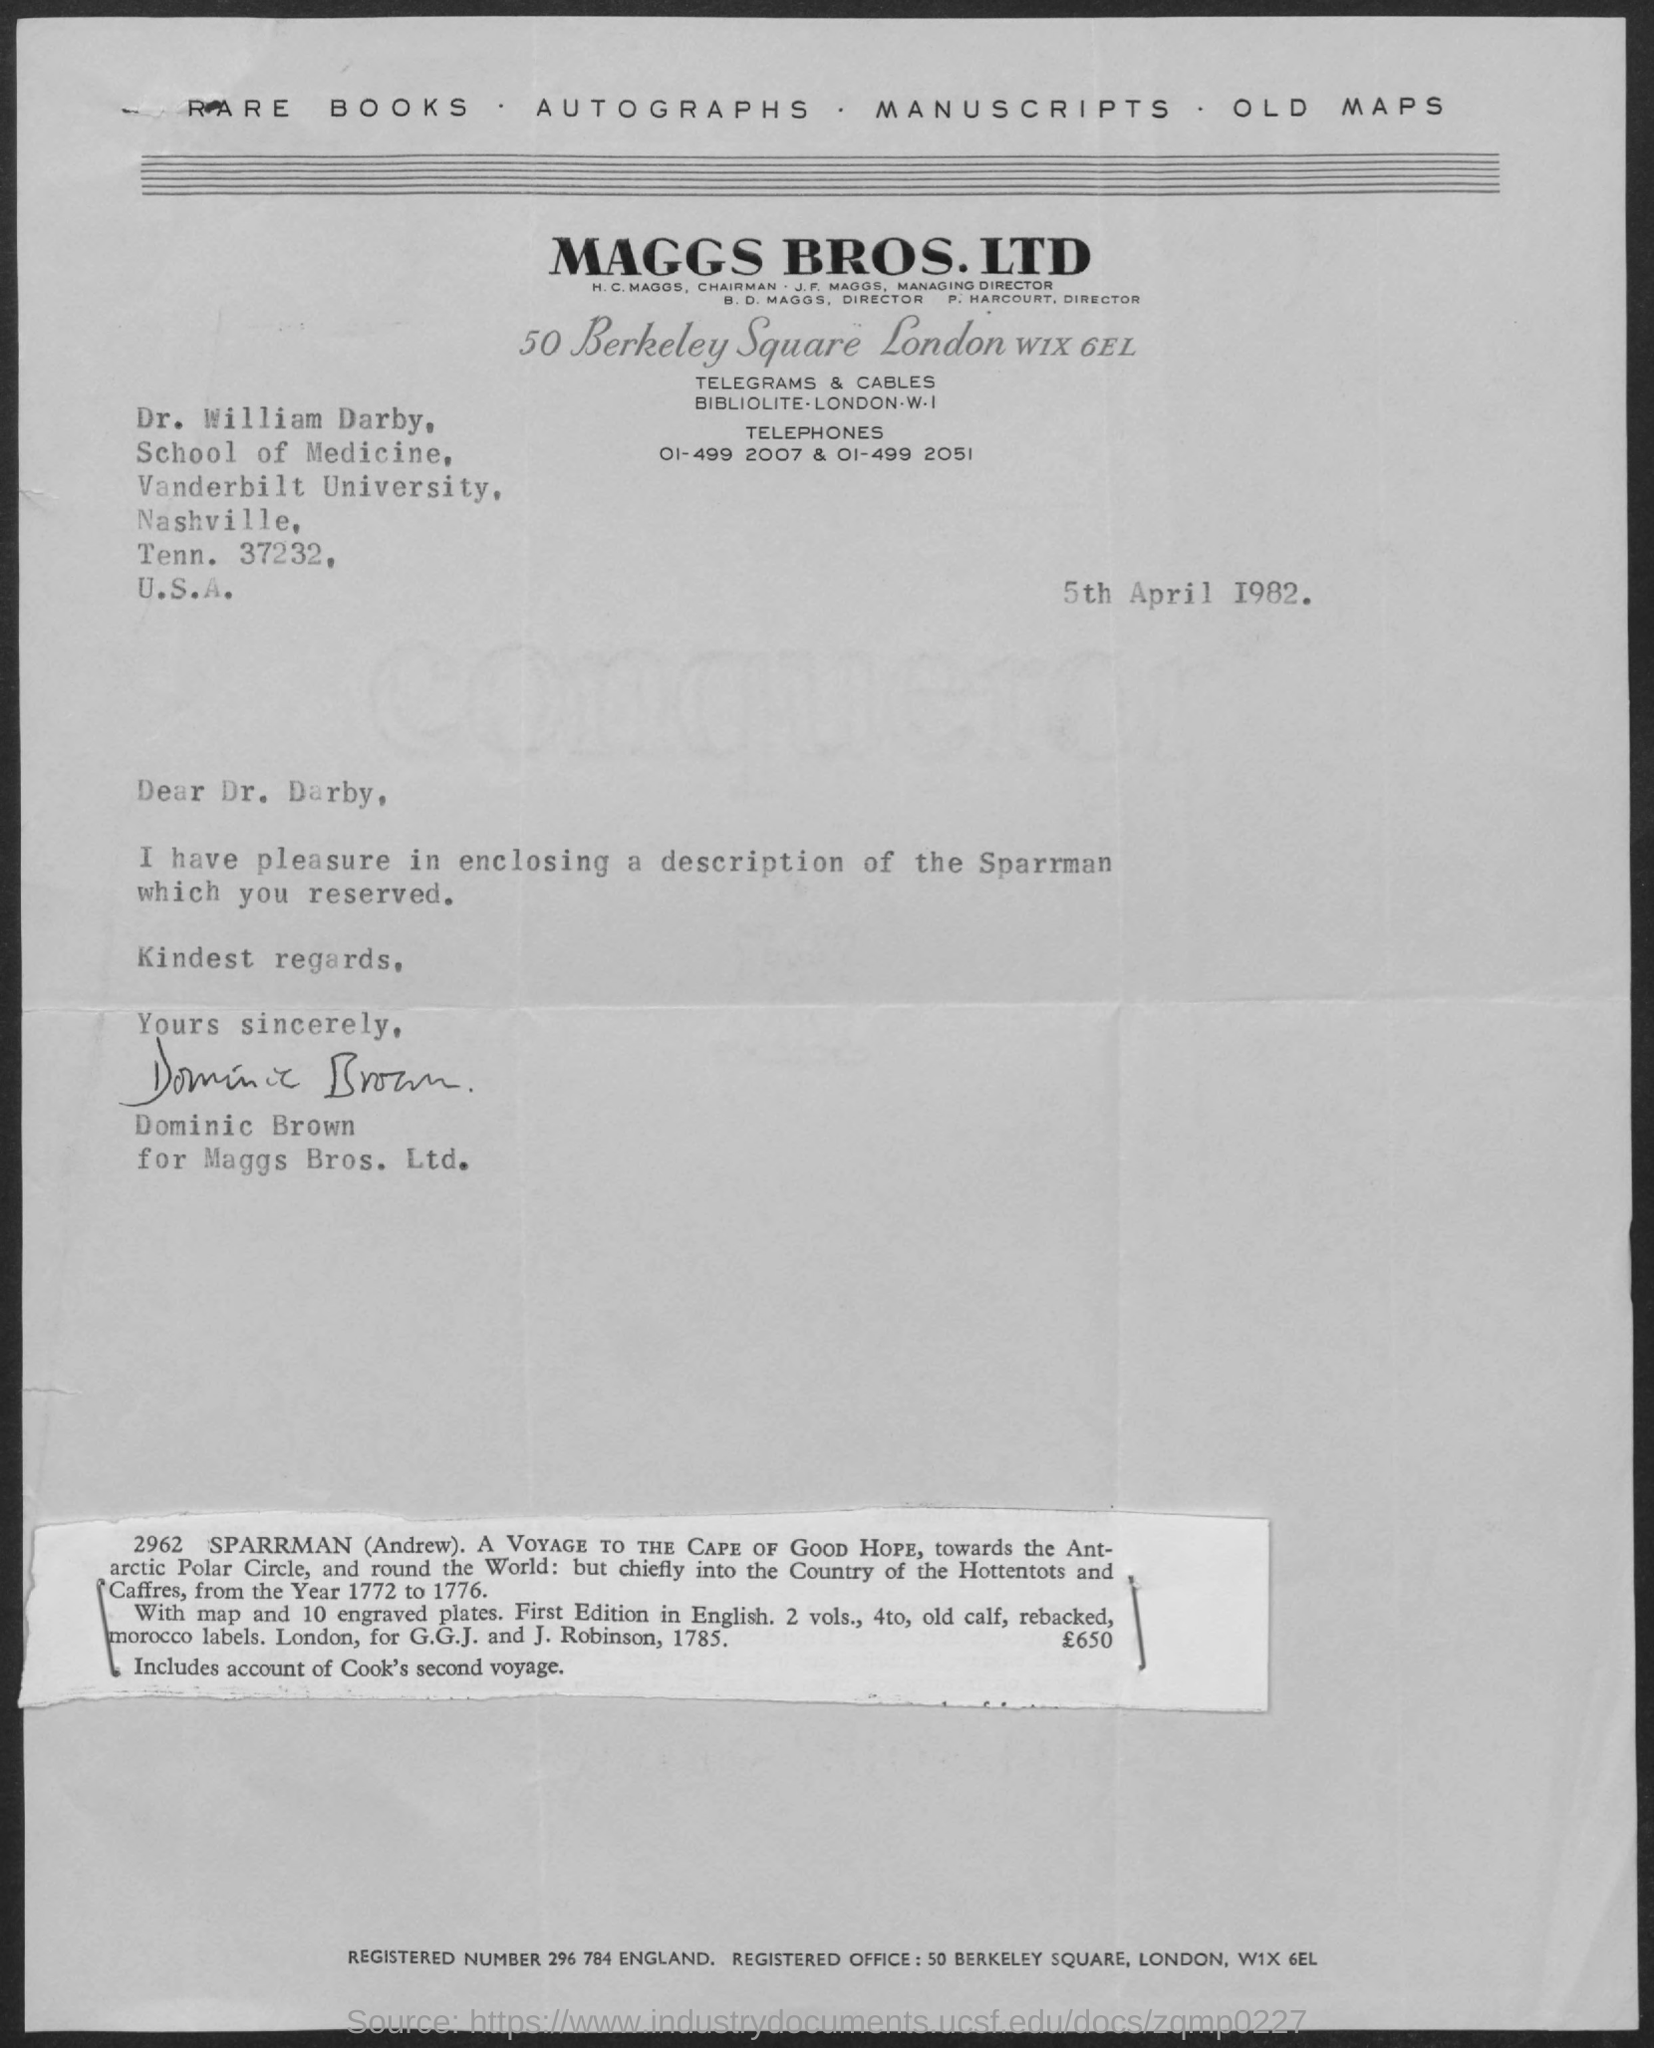Which firm is mentioned at the top of the page?
Ensure brevity in your answer.  Maggs bros. ltd. When is the letter dated?
Make the answer very short. 5th April 1982. To whom is the letter addressed?
Ensure brevity in your answer.  Dr. William Darby. From whom is the letter?
Offer a terse response. Dominic brown. 